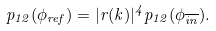Convert formula to latex. <formula><loc_0><loc_0><loc_500><loc_500>p _ { 1 2 } ( \phi _ { r e f } ) = | r ( k ) | ^ { 4 } p _ { 1 2 } ( \phi _ { \overline { i n } } ) .</formula> 